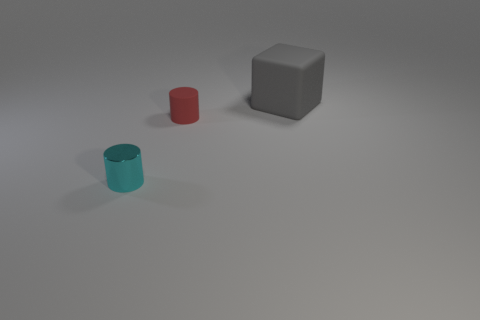There is a small object that is right of the object that is in front of the cylinder that is right of the cyan cylinder; what is its material?
Make the answer very short. Rubber. Is the cyan thing the same size as the red cylinder?
Your response must be concise. Yes. Do the matte cylinder and the large cube behind the metal object have the same color?
Keep it short and to the point. No. What shape is the small red object that is made of the same material as the gray block?
Your answer should be compact. Cylinder. Does the matte thing in front of the cube have the same shape as the tiny cyan shiny thing?
Provide a short and direct response. Yes. There is a thing that is right of the matte thing that is on the left side of the big thing; what size is it?
Keep it short and to the point. Large. There is a small object that is the same material as the big thing; what color is it?
Make the answer very short. Red. What number of red rubber things are the same size as the matte cylinder?
Offer a terse response. 0. How many red things are metallic objects or cubes?
Give a very brief answer. 0. How many objects are either large yellow matte balls or small things that are behind the tiny cyan object?
Keep it short and to the point. 1. 